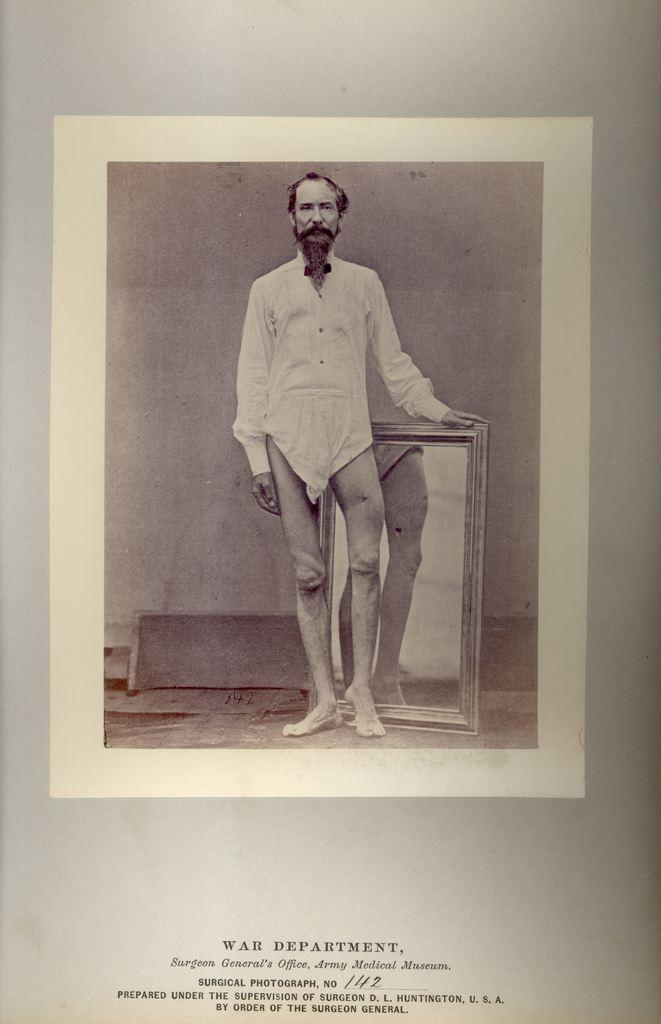What is the main subject of the image? The main subject of the image is a man. What object can be seen reflecting the man in the image? There is a mirror in the image. What is located at the bottom of the image? There is text at the bottom of the image. Can you tell me how many nails the kitten is holding in the image? There is no kitten or nails present in the image. What type of rule is being enforced by the man in the image? There is no rule being enforced by the man in the image; it is not possible to determine this from the provided facts. 